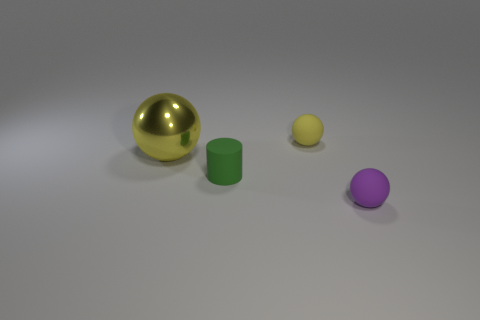Add 3 tiny red matte balls. How many objects exist? 7 Subtract all cylinders. How many objects are left? 3 Add 1 matte spheres. How many matte spheres are left? 3 Add 2 tiny red metal balls. How many tiny red metal balls exist? 2 Subtract 0 red cylinders. How many objects are left? 4 Subtract all green matte cylinders. Subtract all small purple rubber balls. How many objects are left? 2 